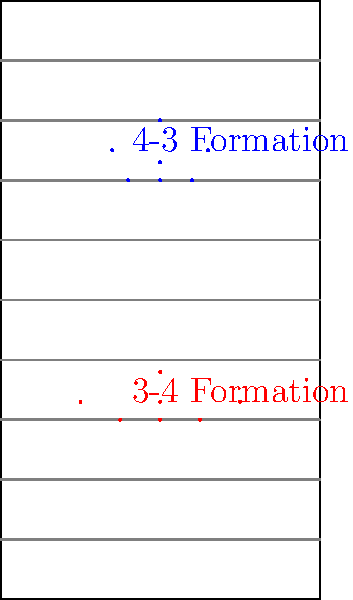Based on the bird's-eye view diagram of two common defensive formations in football, which formation appears to provide better lateral coverage of the field? Consider the distribution of players across the width of the field. To determine which formation provides better lateral coverage, we need to analyze the distribution of players across the width of the field for both formations:

1. 4-3 Formation (Blue):
   - 4 defensive linemen spread across the line of scrimmage
   - 3 linebackers positioned behind the line

2. 3-4 Formation (Red):
   - 3 defensive linemen spread across the line of scrimmage
   - 4 linebackers positioned behind the line

Step 1: Analyze the front line (defensive linemen)
- 4-3 Formation: 4 players spread across the line
- 3-4 Formation: 3 players spread across the line

Step 2: Analyze the second level (linebackers)
- 4-3 Formation: 3 linebackers
- 3-4 Formation: 4 linebackers

Step 3: Consider the overall distribution
The 3-4 Formation has one less player on the front line but compensates with an extra linebacker. This extra linebacker allows for more flexibility in positioning, potentially covering a wider area laterally.

Step 4: Evaluate the spacing
The 3-4 Formation shows wider spacing between players, especially in the linebacker group. This wider distribution allows for better coverage across the width of the field.

Step 5: Consider adaptability
With four linebackers, the 3-4 Formation can more easily adjust to spread offenses and provide better lateral coverage when needed.

Based on this analysis, the 3-4 Formation appears to provide better lateral coverage of the field due to its wider distribution of players and the flexibility provided by the extra linebacker.
Answer: 3-4 Formation 